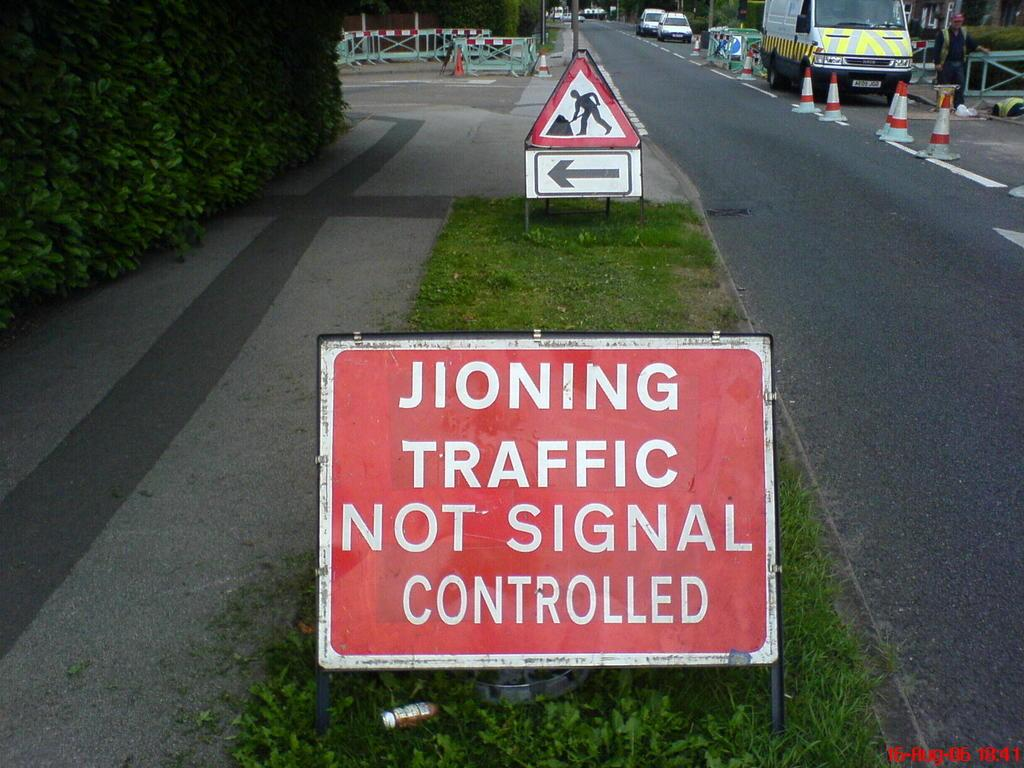<image>
Share a concise interpretation of the image provided. A red sign on the side of a road suggests that traffic is not signal controlled. 